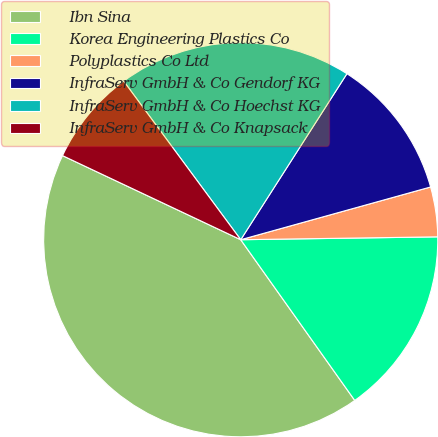<chart> <loc_0><loc_0><loc_500><loc_500><pie_chart><fcel>Ibn Sina<fcel>Korea Engineering Plastics Co<fcel>Polyplastics Co Ltd<fcel>InfraServ GmbH & Co Gendorf KG<fcel>InfraServ GmbH & Co Hoechst KG<fcel>InfraServ GmbH & Co Knapsack<nl><fcel>41.84%<fcel>15.41%<fcel>4.08%<fcel>11.63%<fcel>19.18%<fcel>7.86%<nl></chart> 